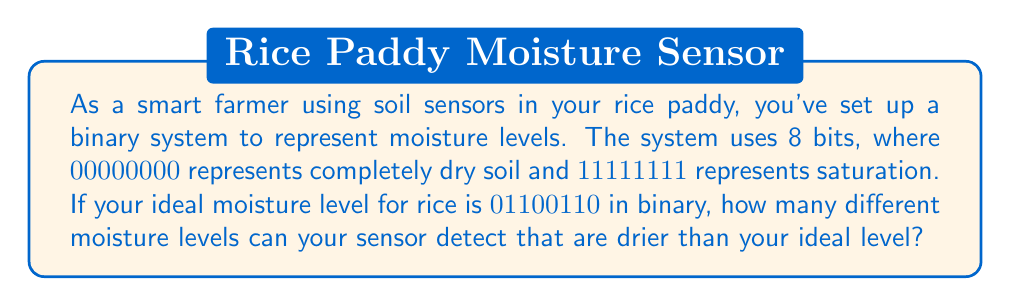Can you answer this question? To solve this problem, we need to understand binary numbers and how they represent values. Let's break it down step-by-step:

1) In an 8-bit binary system, we have $2^8 = 256$ possible values, ranging from 00000000 to 11111111.

2) The ideal moisture level is given as 01100110 in binary. We need to convert this to decimal to understand its position in the range:

   $01100110_2 = 0\cdot2^7 + 1\cdot2^6 + 1\cdot2^5 + 0\cdot2^4 + 0\cdot2^3 + 1\cdot2^2 + 1\cdot2^1 + 0\cdot2^0$
   $= 0 + 64 + 32 + 0 + 0 + 4 + 2 + 0 = 102$

3) This means that 102 represents our ideal moisture level.

4) All numbers from 00000000 (0 in decimal) to 01100101 (101 in decimal) represent moisture levels drier than the ideal.

5) To count how many levels this includes, we simply need to count from 0 to 101, which is 102 numbers.

Therefore, there are 102 moisture levels that the sensor can detect that are drier than the ideal level.
Answer: 102 moisture levels 